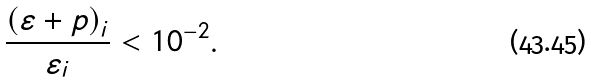Convert formula to latex. <formula><loc_0><loc_0><loc_500><loc_500>\frac { \left ( \varepsilon + p \right ) _ { i } } { \varepsilon _ { i } } < 1 0 ^ { - 2 } .</formula> 